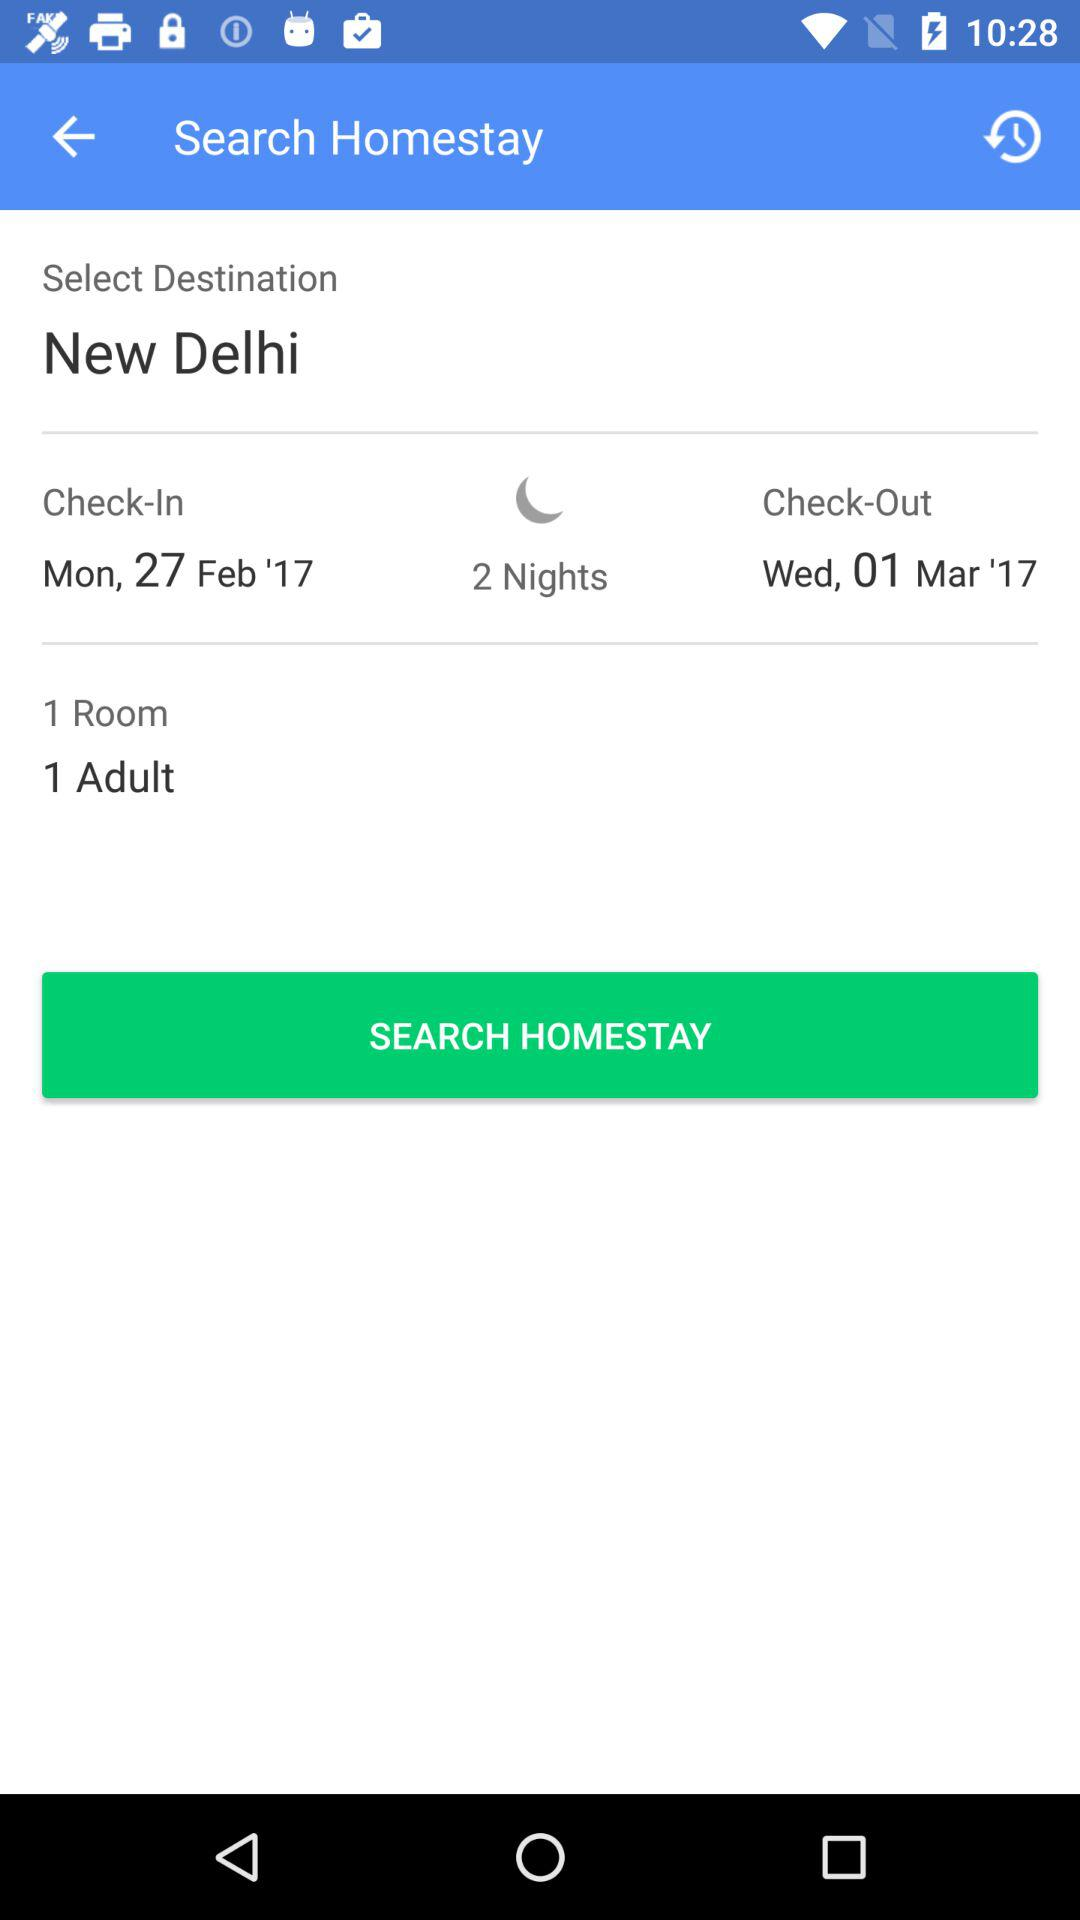What is the check-out date? The check-out date is Wednesday, March 1, 2017. 